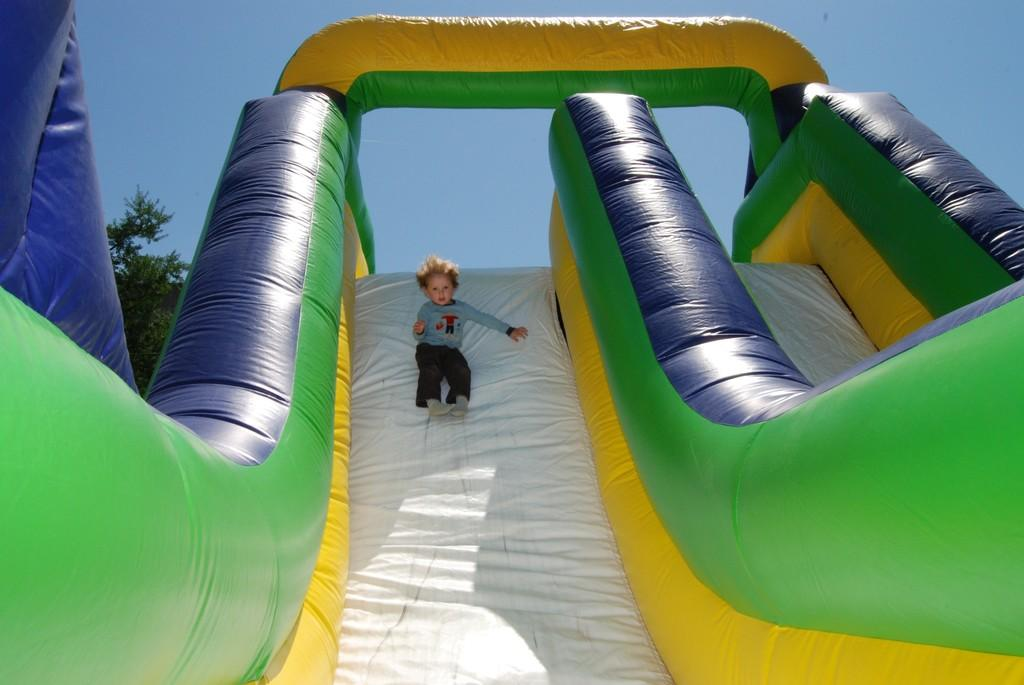What is the main subject of the image? There is a child in the image. What is the child doing in the image? The child is sliding on an inflatable object. What can be seen in the background of the image? There are trees in the background of the image. What color is the sky in the image? The sky is blue in the image. What scientific theory is the child discussing with the trees in the image? There is no indication in the image that the child is discussing any scientific theory with the trees. How many hands does the child have in the image? The image does not show the child's hands, so it cannot be determined how many hands they have. 